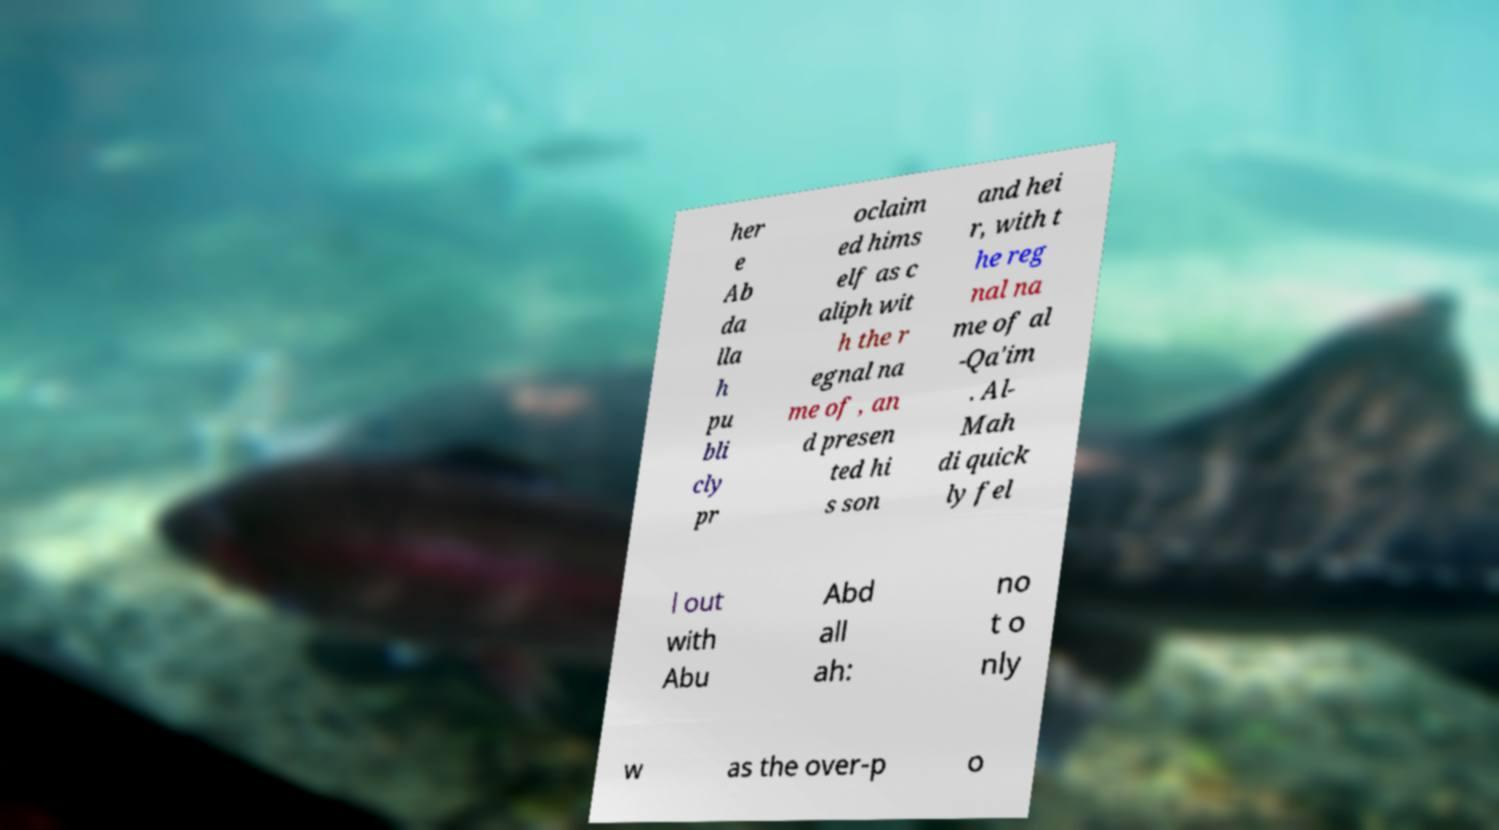Please read and relay the text visible in this image. What does it say? her e Ab da lla h pu bli cly pr oclaim ed hims elf as c aliph wit h the r egnal na me of , an d presen ted hi s son and hei r, with t he reg nal na me of al -Qa'im . Al- Mah di quick ly fel l out with Abu Abd all ah: no t o nly w as the over-p o 